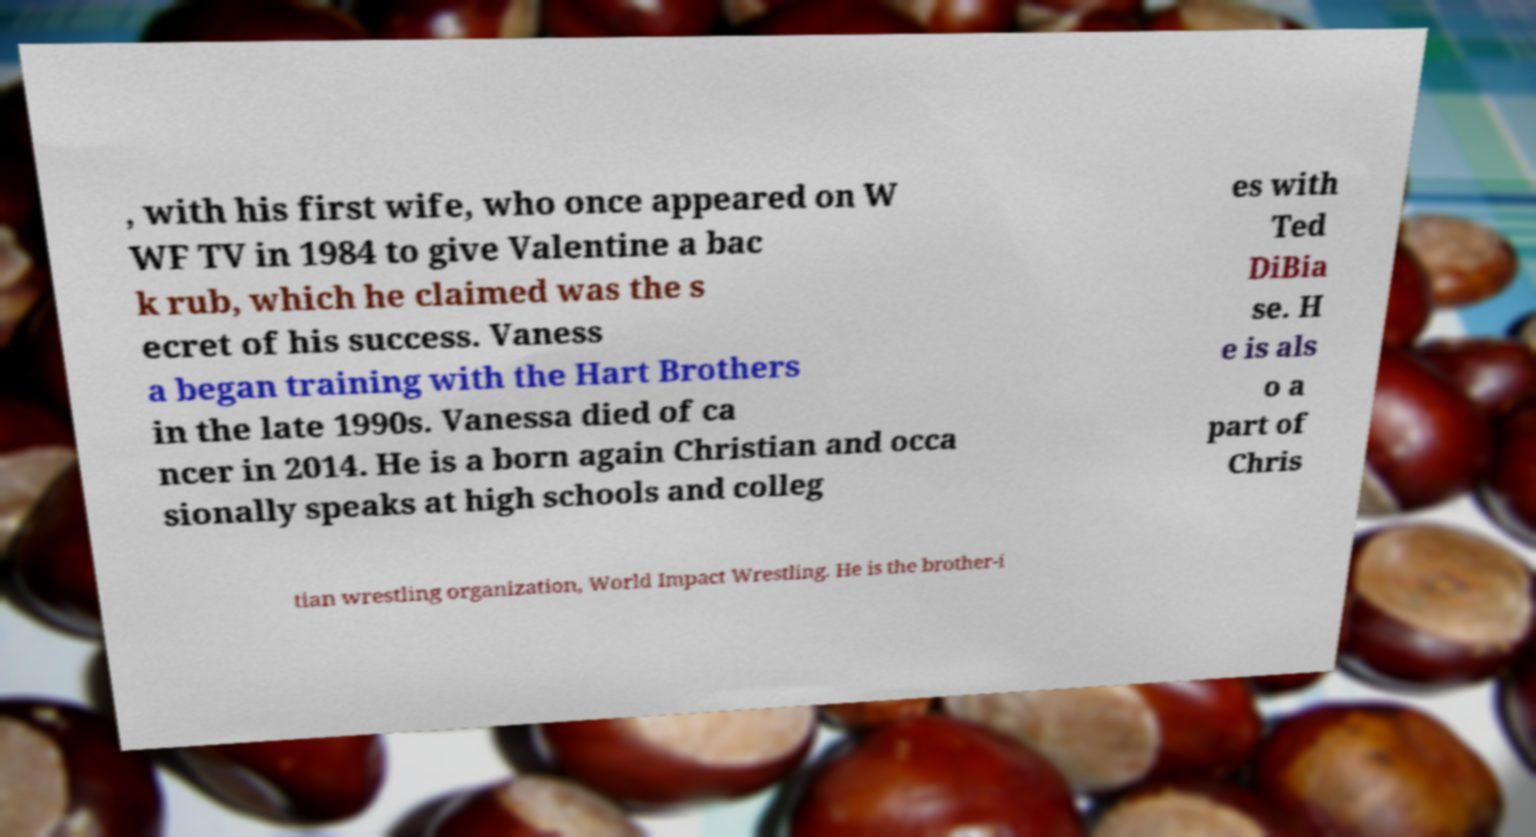Please identify and transcribe the text found in this image. , with his first wife, who once appeared on W WF TV in 1984 to give Valentine a bac k rub, which he claimed was the s ecret of his success. Vaness a began training with the Hart Brothers in the late 1990s. Vanessa died of ca ncer in 2014. He is a born again Christian and occa sionally speaks at high schools and colleg es with Ted DiBia se. H e is als o a part of Chris tian wrestling organization, World Impact Wrestling. He is the brother-i 